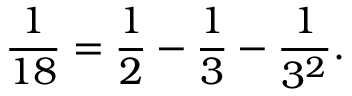Convert formula to latex. <formula><loc_0><loc_0><loc_500><loc_500>{ \frac { 1 } { 1 8 } } = { \frac { 1 } { 2 } } - { \frac { 1 } { 3 } } - { \frac { 1 } { 3 ^ { 2 } } } .</formula> 